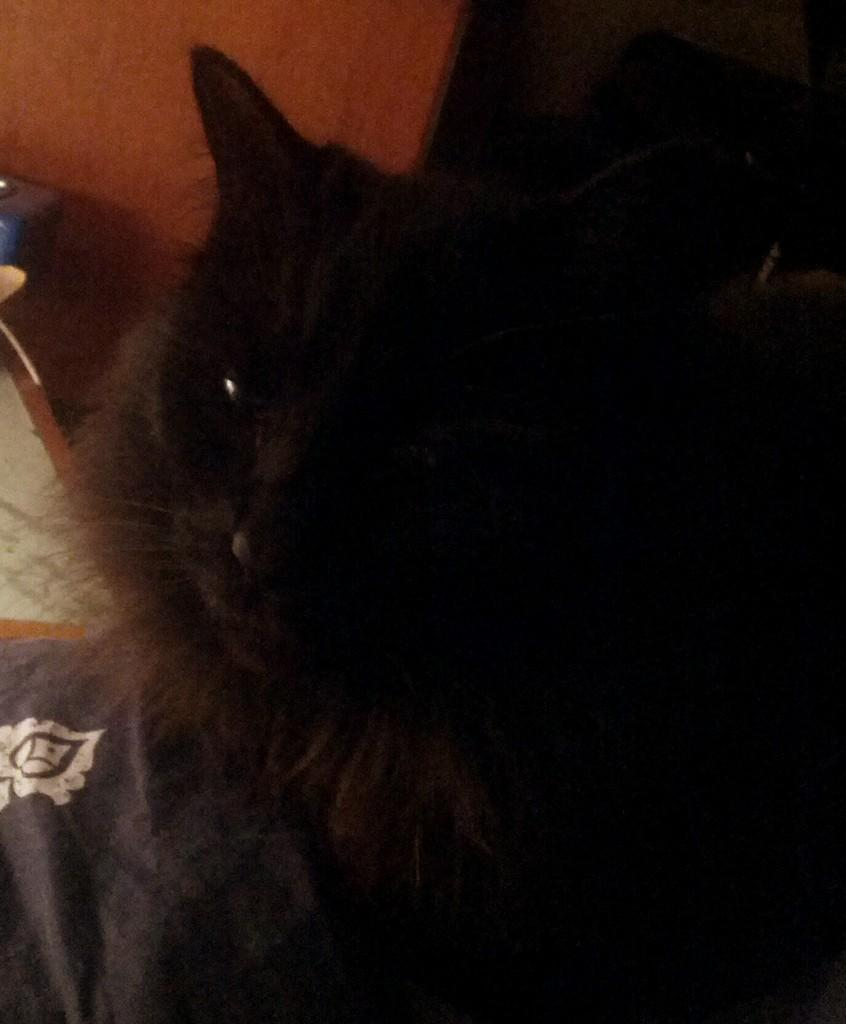What type of animal is in the image? There is a cat in the image. What color is the cat? The cat is black in color. Where is the cat located in the image? The cat is in the middle of the image. What can be seen around the cat in the image? There are objects visible to the side of the cat. What is the shocking way the stem is growing in the image? There is no stem present in the image, so it is not possible to answer a question about its growth. 